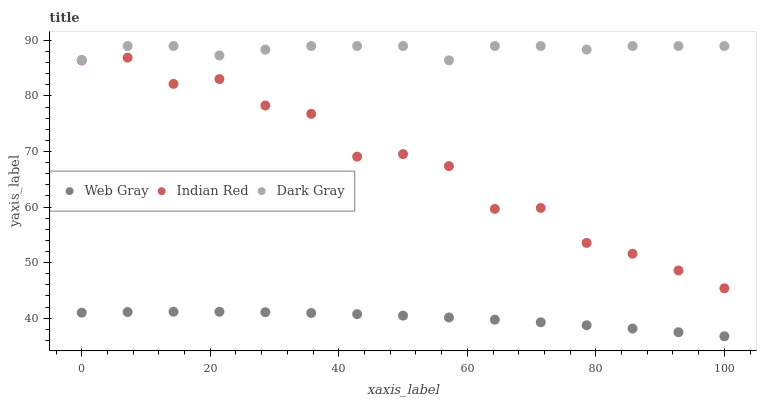Does Web Gray have the minimum area under the curve?
Answer yes or no. Yes. Does Dark Gray have the maximum area under the curve?
Answer yes or no. Yes. Does Indian Red have the minimum area under the curve?
Answer yes or no. No. Does Indian Red have the maximum area under the curve?
Answer yes or no. No. Is Web Gray the smoothest?
Answer yes or no. Yes. Is Indian Red the roughest?
Answer yes or no. Yes. Is Indian Red the smoothest?
Answer yes or no. No. Is Web Gray the roughest?
Answer yes or no. No. Does Web Gray have the lowest value?
Answer yes or no. Yes. Does Indian Red have the lowest value?
Answer yes or no. No. Does Dark Gray have the highest value?
Answer yes or no. Yes. Does Indian Red have the highest value?
Answer yes or no. No. Is Web Gray less than Dark Gray?
Answer yes or no. Yes. Is Indian Red greater than Web Gray?
Answer yes or no. Yes. Does Web Gray intersect Dark Gray?
Answer yes or no. No. 